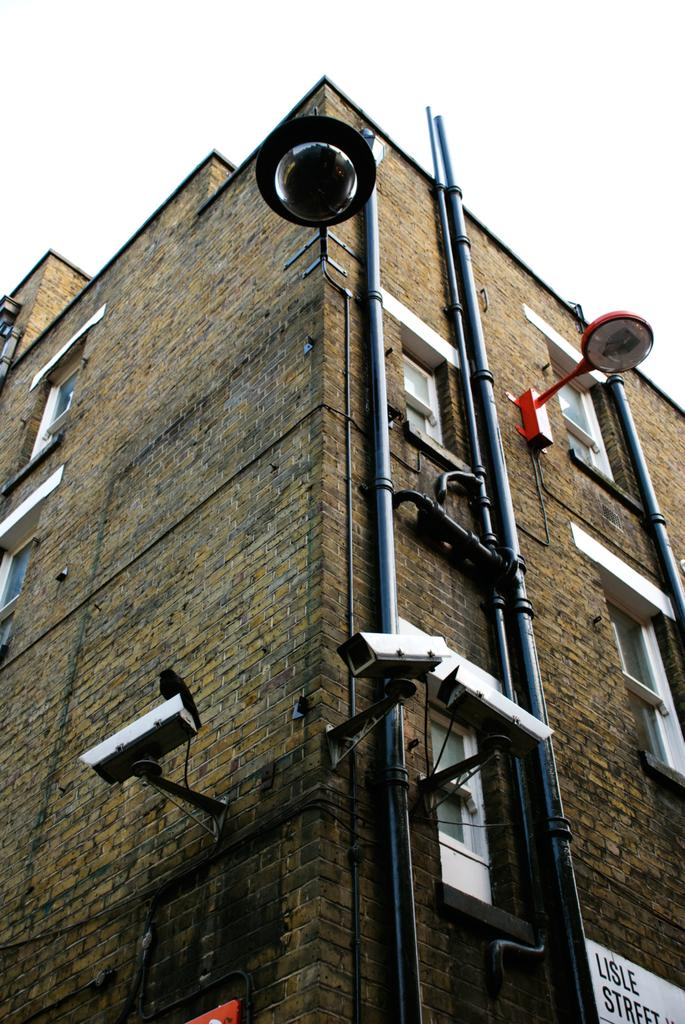What type of structures can be seen in the image? There are poles in the image. What devices are present for surveillance purposes? There are CCTV cameras in the image. What type of illumination is visible in the image? There are lights in the image. What type of location might these objects be associated with? These objects are associated with a building. How many girls are present in the image? There are no girls present in the image. What type of animal can be seen grazing near the building in the image? There are no animals, such as deer, present in the image. 